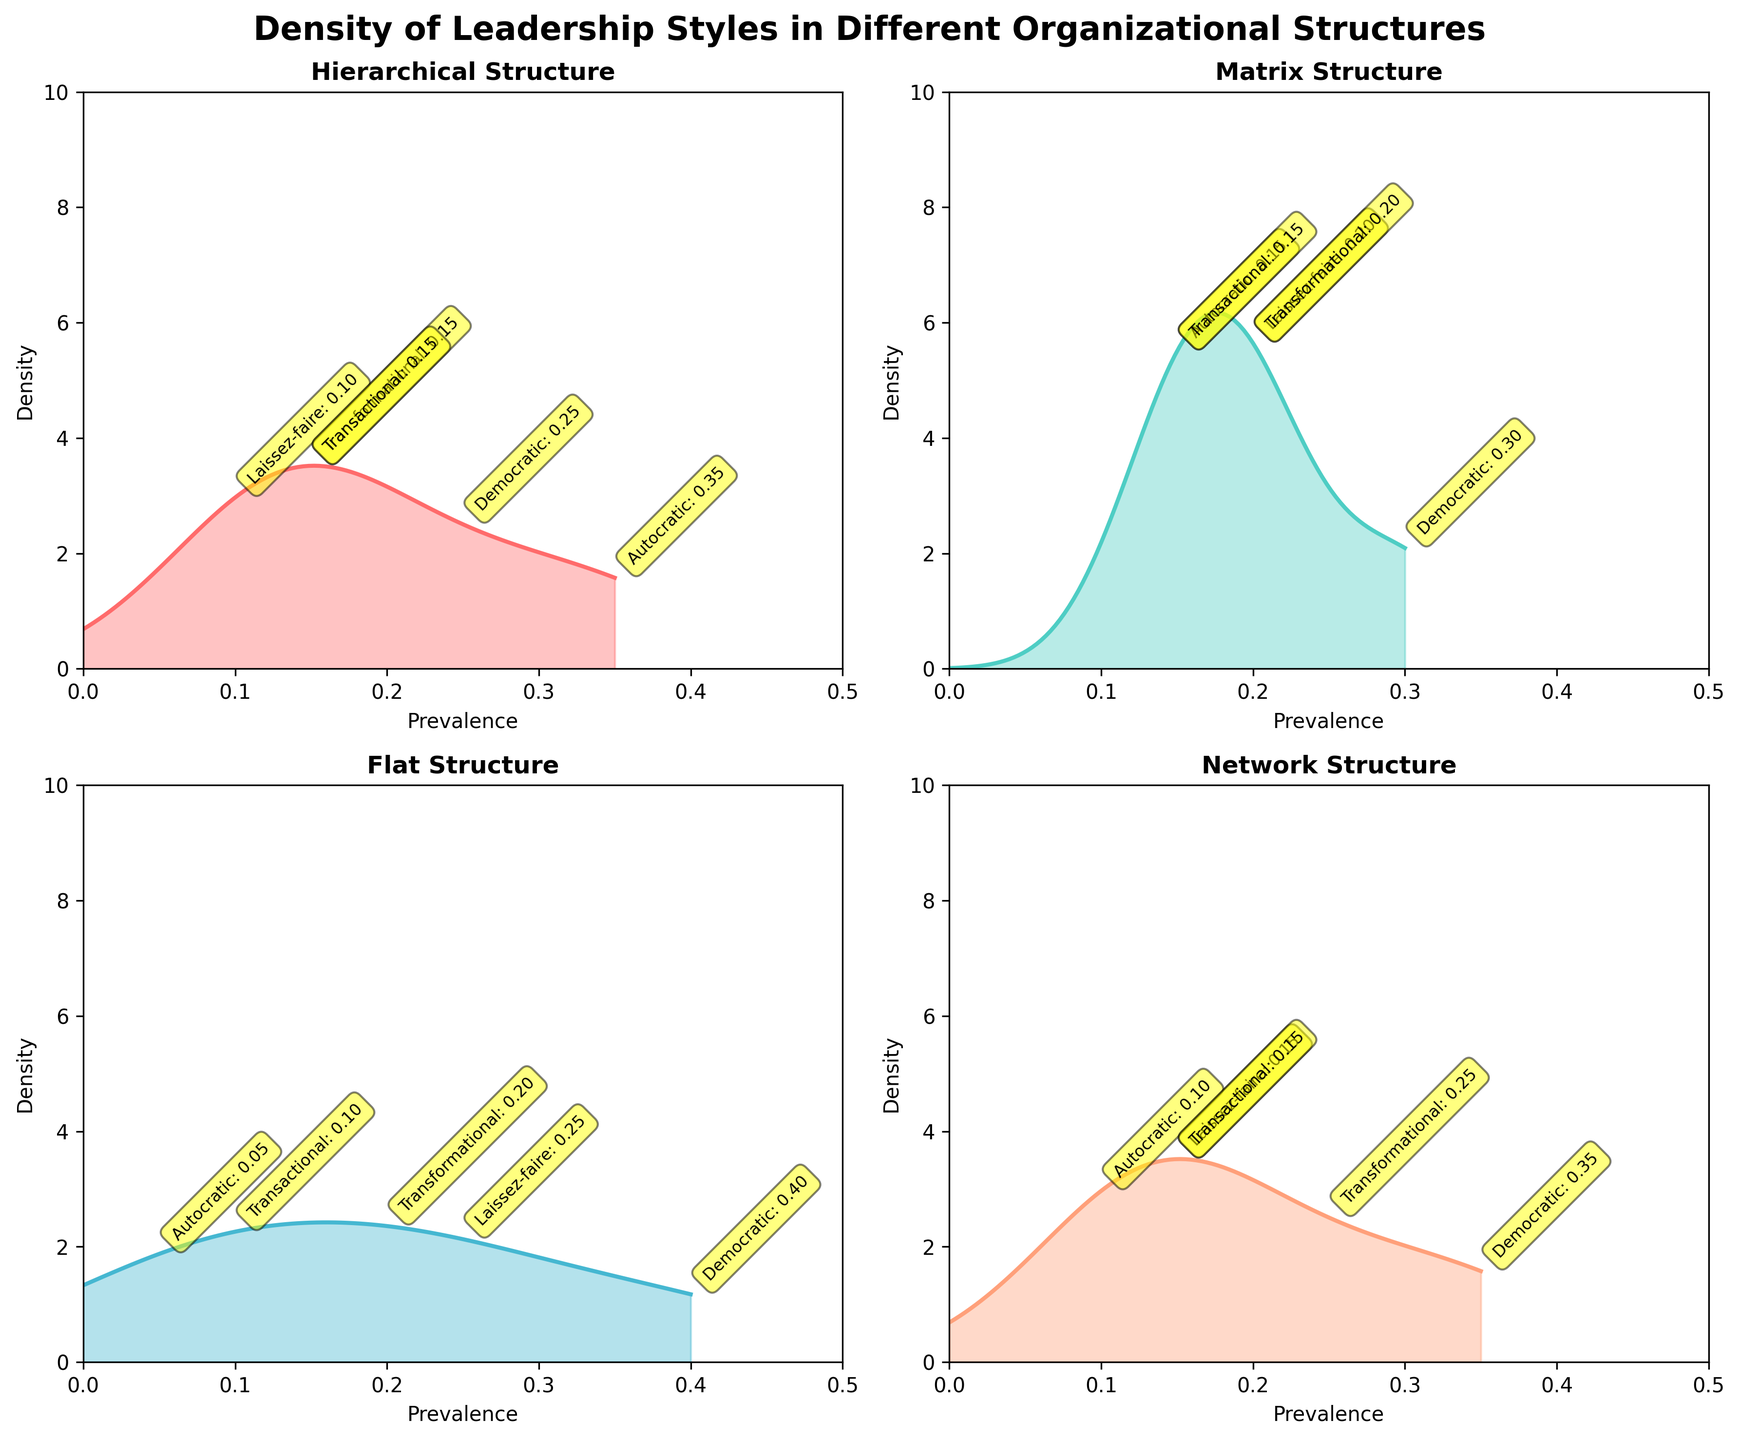Which organizational structure shows the highest density for the Democratic leadership style? To find the highest density for the Democratic leadership style, look for the tallest peak in the density curves for this leadership style across all subplots. The Democratic leadership style is at its peak in the Flat structure.
Answer: Flat Which leadership style has the lowest prevalence in the Hierarchical structure? Examine the Hierarchical subplot and identify the leadership style with the smallest value. Autocratic has a prevalence of 0.35, Democratic of 0.25, Laissez-faire of 0.10, Transformational of 0.15, and Transactional of 0.15. Therefore, Laissez-faire has the lowest prevalence with a value of 0.10.
Answer: Laissez-faire How does the prevalence of Transformational leadership in the Network structure compare to that in the Matrix structure? In the Network plot, find the Transformational leadership prevalence (0.25) and compare it to the Transformational prevalence in the Matrix plot (0.20). Transformational leadership is more prevalent in the Network structure than in the Matrix structure.
Answer: More prevalent in Network What is the combined density value at the prevalence of Democratic leadership for both the Matrix and Network structures? Locate the Democratic value in both the Matrix and Network subplots (0.30 and 0.35, respectively). Find their `kde` density values for these points and sum them up. For this, you need to observe the height (density value) of the curve at these prevalence points for both structures. Let's assume the sum of the density values at these points is approximately 3.8.
Answer: Approximately 3.8 Which structure has the most balanced density distribution among all leadership styles? A balanced density distribution would show relatively even peaks across all leadership styles compared to other structures. Observing the subplots, the Matrix structure shows a more balanced distribution, because the peaks are less skewed compared to other structures.
Answer: Matrix In the Hierarchical structure, which leadership style's density is closest to the origin? In the Hierarchical subplot, find the density curve closest to the origin (0 on the x-axis). The Autocratic leadership style, with a prevalence of 0.35, has its density curve farthest from the origin, while Laissez-faire at 0.10 is the closest.
Answer: Laissez-faire Based on the Network structure, which leadership styles are more prevalent than Transactional? Compare the prevalence values of each leadership style in the Network structure. Transformational (0.25), Democratic (0.35), and Laissez-faire (0.15). All these, except Laissez-faire (which is equal), are more prevalent than Transactional (0.15).
Answer: Transformational, Democratic What makes the Flat structure distinct in terms of leadership style density? The Flat structure is distinct because the Democratic leadership style has the highest prevalence (0.40) among all structures, and its density curve peaks significantly compared to other leadership styles within the same structure.
Answer: Highest Democratic prevalence 